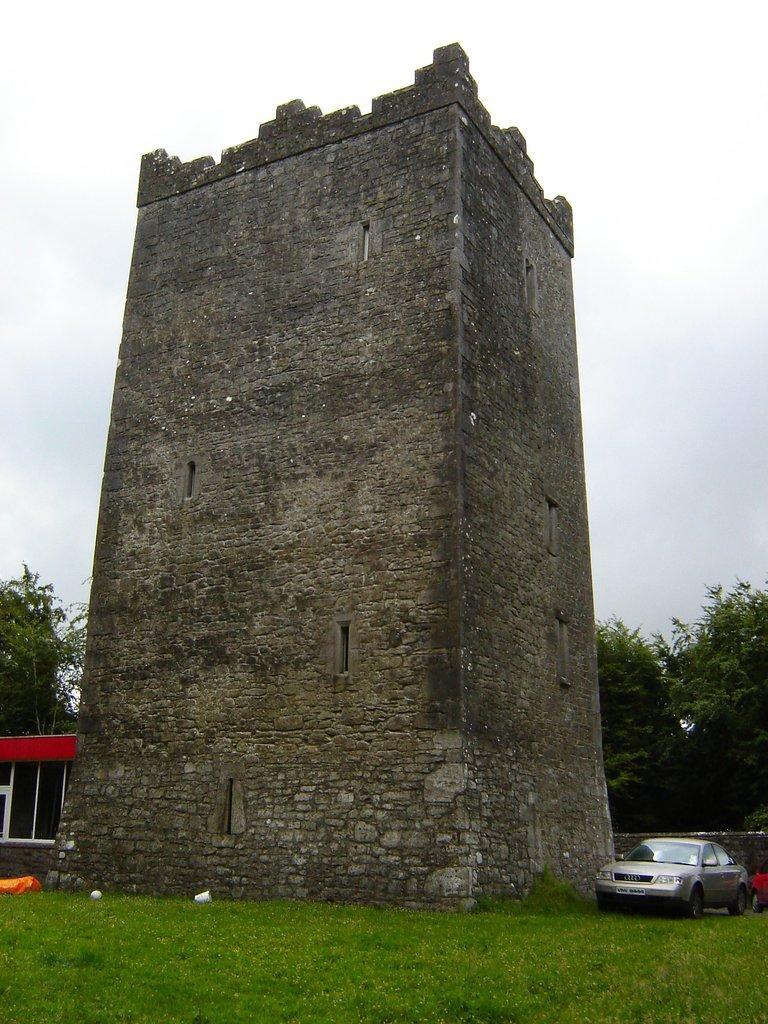Please provide a concise description of this image. In the center of the image, we can see an old building and there are trees and we can see a shed and some vehicles and some other objects on the ground. At the top, there is sky. 